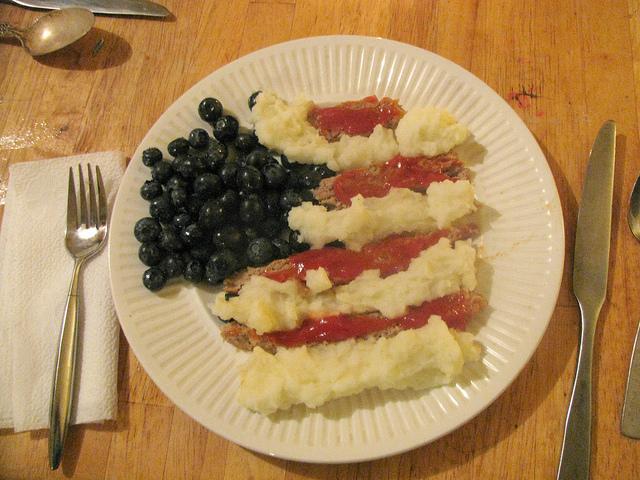What color is the spoon?
Quick response, please. Silver. Will this be eaten by one person?
Be succinct. Yes. Is this the correct way to set a table?
Answer briefly. Yes. How many utensils can be seen?
Answer briefly. 5. 